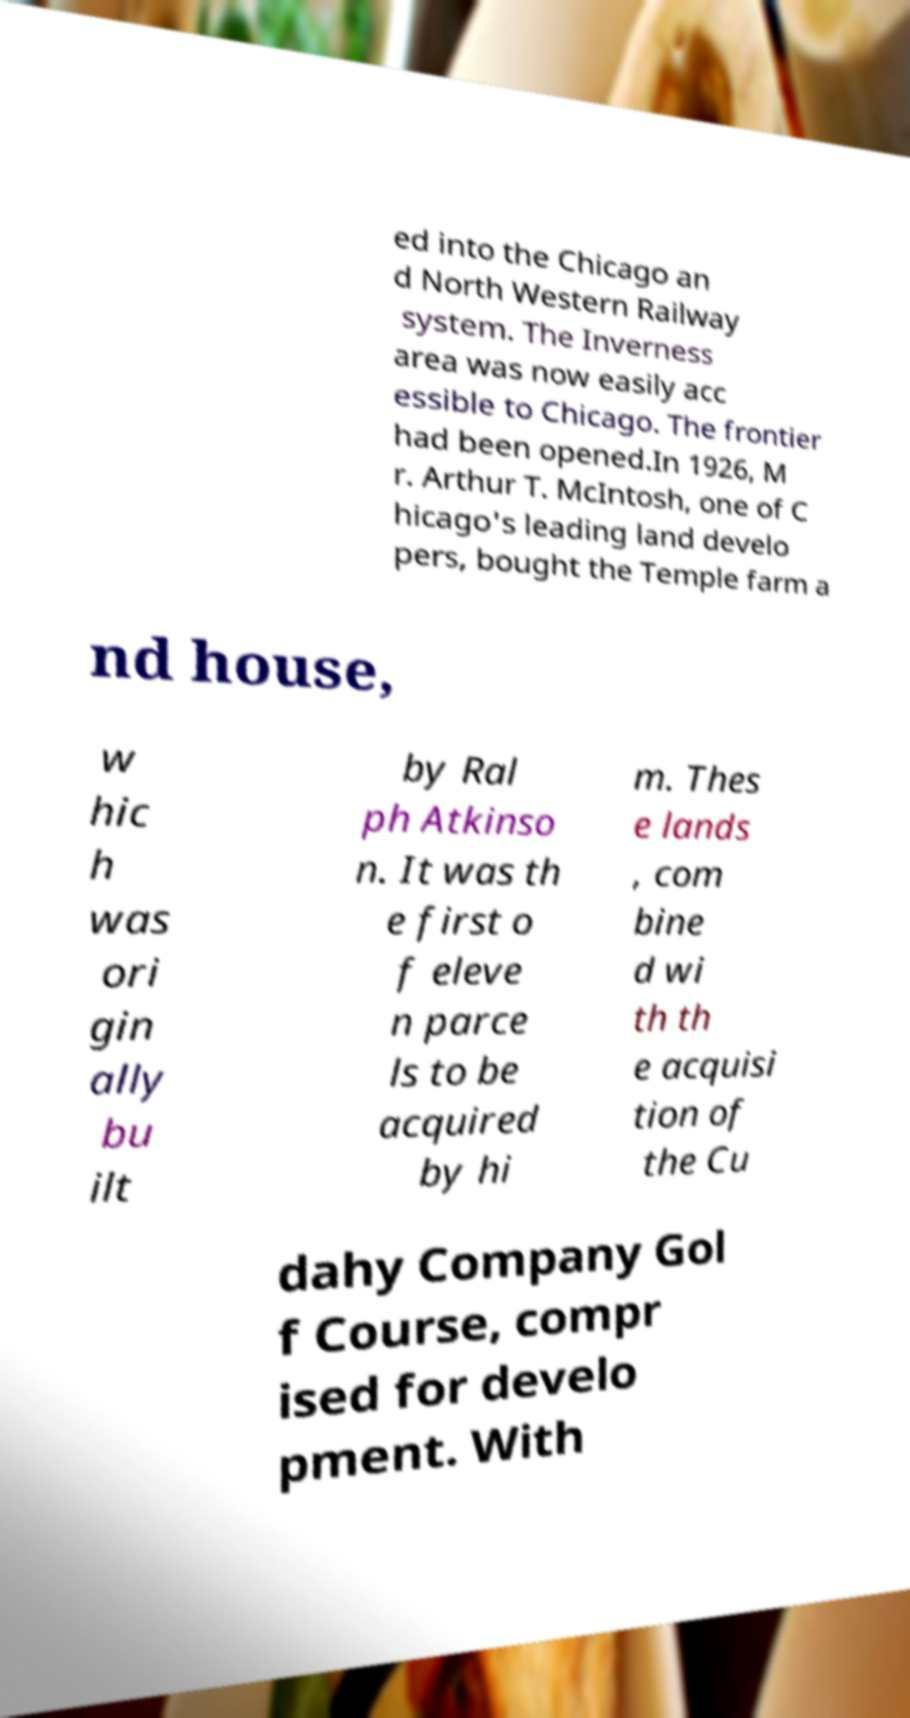What messages or text are displayed in this image? I need them in a readable, typed format. ed into the Chicago an d North Western Railway system. The Inverness area was now easily acc essible to Chicago. The frontier had been opened.In 1926, M r. Arthur T. McIntosh, one of C hicago's leading land develo pers, bought the Temple farm a nd house, w hic h was ori gin ally bu ilt by Ral ph Atkinso n. It was th e first o f eleve n parce ls to be acquired by hi m. Thes e lands , com bine d wi th th e acquisi tion of the Cu dahy Company Gol f Course, compr ised for develo pment. With 